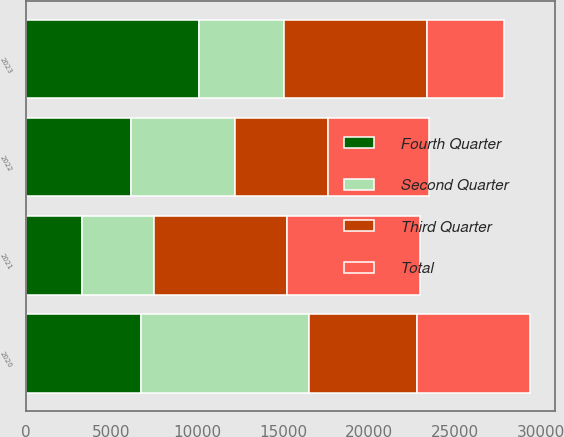Convert chart to OTSL. <chart><loc_0><loc_0><loc_500><loc_500><stacked_bar_chart><ecel><fcel>2020<fcel>2021<fcel>2022<fcel>2023<nl><fcel>Fourth Quarter<fcel>6740<fcel>3288<fcel>6151<fcel>10076<nl><fcel>Second Quarter<fcel>9744<fcel>4162<fcel>6067<fcel>4958<nl><fcel>Third Quarter<fcel>6308<fcel>7790<fcel>5365<fcel>8343<nl><fcel>Total<fcel>6579<fcel>7724<fcel>5876<fcel>4495<nl></chart> 